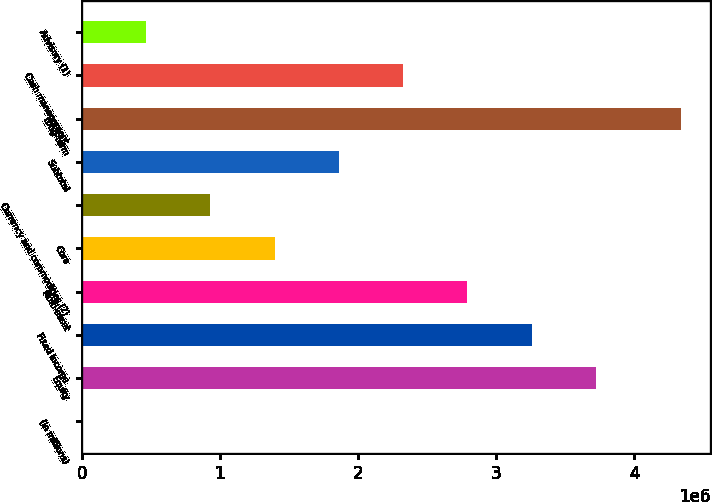<chart> <loc_0><loc_0><loc_500><loc_500><bar_chart><fcel>(in millions)<fcel>Equity<fcel>Fixed income<fcel>Multi-asset<fcel>Core<fcel>Currency and commodities (2)<fcel>Subtotal<fcel>Long-term<fcel>Cash management<fcel>Advisory (1)<nl><fcel>2014<fcel>3.72192e+06<fcel>3.25693e+06<fcel>2.79194e+06<fcel>1.39698e+06<fcel>931990<fcel>1.86197e+06<fcel>4.33384e+06<fcel>2.32695e+06<fcel>467002<nl></chart> 